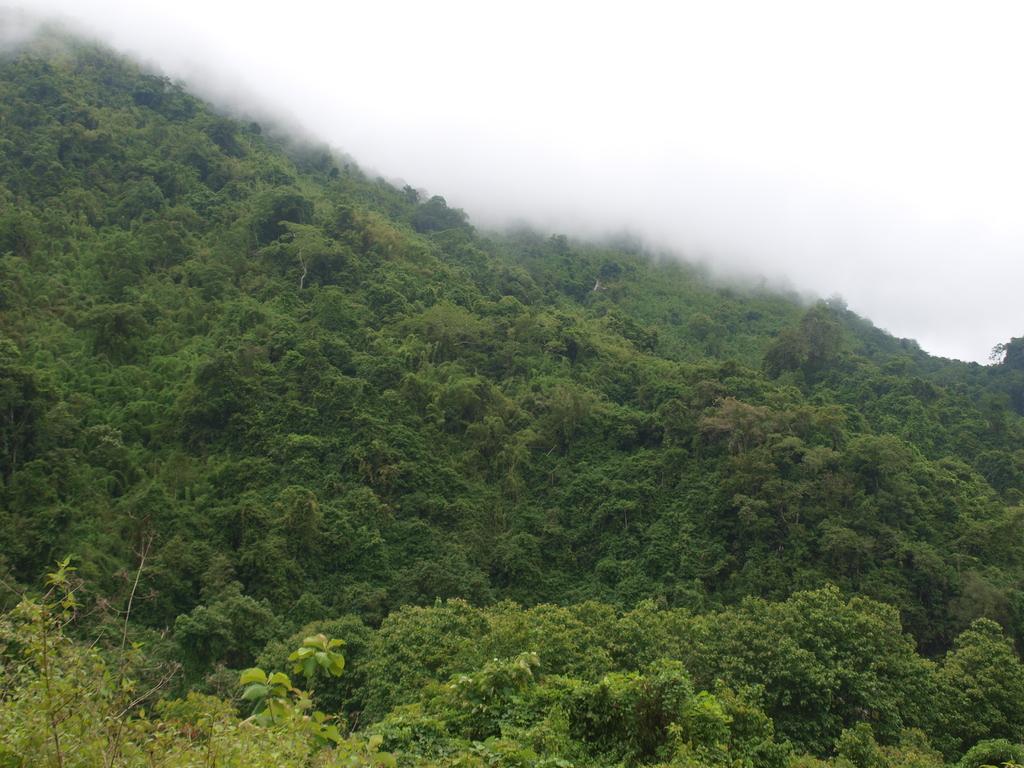In one or two sentences, can you explain what this image depicts? In this image we can see hill, plants, fog and sky. 